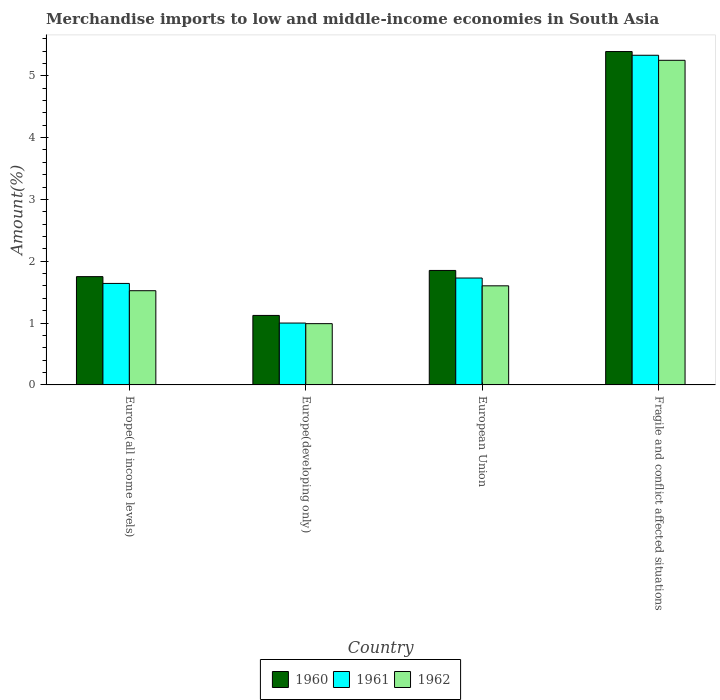How many different coloured bars are there?
Provide a short and direct response. 3. What is the label of the 4th group of bars from the left?
Your response must be concise. Fragile and conflict affected situations. What is the percentage of amount earned from merchandise imports in 1961 in Europe(developing only)?
Make the answer very short. 1. Across all countries, what is the maximum percentage of amount earned from merchandise imports in 1960?
Provide a short and direct response. 5.39. Across all countries, what is the minimum percentage of amount earned from merchandise imports in 1962?
Give a very brief answer. 0.99. In which country was the percentage of amount earned from merchandise imports in 1962 maximum?
Ensure brevity in your answer.  Fragile and conflict affected situations. In which country was the percentage of amount earned from merchandise imports in 1961 minimum?
Your answer should be compact. Europe(developing only). What is the total percentage of amount earned from merchandise imports in 1961 in the graph?
Offer a very short reply. 9.7. What is the difference between the percentage of amount earned from merchandise imports in 1962 in Europe(all income levels) and that in Fragile and conflict affected situations?
Your response must be concise. -3.73. What is the difference between the percentage of amount earned from merchandise imports in 1962 in Europe(developing only) and the percentage of amount earned from merchandise imports in 1960 in Fragile and conflict affected situations?
Offer a very short reply. -4.4. What is the average percentage of amount earned from merchandise imports in 1960 per country?
Provide a succinct answer. 2.53. What is the difference between the percentage of amount earned from merchandise imports of/in 1962 and percentage of amount earned from merchandise imports of/in 1961 in European Union?
Provide a short and direct response. -0.13. In how many countries, is the percentage of amount earned from merchandise imports in 1962 greater than 5.2 %?
Make the answer very short. 1. What is the ratio of the percentage of amount earned from merchandise imports in 1962 in Europe(all income levels) to that in European Union?
Your answer should be very brief. 0.95. Is the difference between the percentage of amount earned from merchandise imports in 1962 in Europe(developing only) and European Union greater than the difference between the percentage of amount earned from merchandise imports in 1961 in Europe(developing only) and European Union?
Give a very brief answer. Yes. What is the difference between the highest and the second highest percentage of amount earned from merchandise imports in 1961?
Provide a short and direct response. -3.6. What is the difference between the highest and the lowest percentage of amount earned from merchandise imports in 1960?
Keep it short and to the point. 4.27. In how many countries, is the percentage of amount earned from merchandise imports in 1960 greater than the average percentage of amount earned from merchandise imports in 1960 taken over all countries?
Your response must be concise. 1. Is the sum of the percentage of amount earned from merchandise imports in 1961 in Europe(all income levels) and European Union greater than the maximum percentage of amount earned from merchandise imports in 1962 across all countries?
Your answer should be compact. No. What does the 3rd bar from the left in Europe(developing only) represents?
Your response must be concise. 1962. How many countries are there in the graph?
Keep it short and to the point. 4. Does the graph contain any zero values?
Your answer should be compact. No. Where does the legend appear in the graph?
Your answer should be compact. Bottom center. How many legend labels are there?
Ensure brevity in your answer.  3. What is the title of the graph?
Offer a terse response. Merchandise imports to low and middle-income economies in South Asia. Does "1993" appear as one of the legend labels in the graph?
Make the answer very short. No. What is the label or title of the X-axis?
Keep it short and to the point. Country. What is the label or title of the Y-axis?
Make the answer very short. Amount(%). What is the Amount(%) in 1960 in Europe(all income levels)?
Give a very brief answer. 1.75. What is the Amount(%) of 1961 in Europe(all income levels)?
Your answer should be very brief. 1.64. What is the Amount(%) in 1962 in Europe(all income levels)?
Provide a succinct answer. 1.52. What is the Amount(%) of 1960 in Europe(developing only)?
Your answer should be compact. 1.12. What is the Amount(%) of 1961 in Europe(developing only)?
Your answer should be very brief. 1. What is the Amount(%) in 1962 in Europe(developing only)?
Your answer should be very brief. 0.99. What is the Amount(%) of 1960 in European Union?
Provide a succinct answer. 1.85. What is the Amount(%) of 1961 in European Union?
Keep it short and to the point. 1.73. What is the Amount(%) in 1962 in European Union?
Ensure brevity in your answer.  1.6. What is the Amount(%) of 1960 in Fragile and conflict affected situations?
Provide a short and direct response. 5.39. What is the Amount(%) of 1961 in Fragile and conflict affected situations?
Your answer should be very brief. 5.33. What is the Amount(%) in 1962 in Fragile and conflict affected situations?
Give a very brief answer. 5.25. Across all countries, what is the maximum Amount(%) in 1960?
Your answer should be compact. 5.39. Across all countries, what is the maximum Amount(%) of 1961?
Provide a short and direct response. 5.33. Across all countries, what is the maximum Amount(%) of 1962?
Ensure brevity in your answer.  5.25. Across all countries, what is the minimum Amount(%) of 1960?
Keep it short and to the point. 1.12. Across all countries, what is the minimum Amount(%) in 1961?
Your response must be concise. 1. Across all countries, what is the minimum Amount(%) of 1962?
Your response must be concise. 0.99. What is the total Amount(%) of 1960 in the graph?
Your answer should be compact. 10.12. What is the total Amount(%) in 1961 in the graph?
Keep it short and to the point. 9.7. What is the total Amount(%) in 1962 in the graph?
Keep it short and to the point. 9.37. What is the difference between the Amount(%) of 1960 in Europe(all income levels) and that in Europe(developing only)?
Provide a short and direct response. 0.63. What is the difference between the Amount(%) of 1961 in Europe(all income levels) and that in Europe(developing only)?
Give a very brief answer. 0.64. What is the difference between the Amount(%) of 1962 in Europe(all income levels) and that in Europe(developing only)?
Provide a short and direct response. 0.53. What is the difference between the Amount(%) in 1960 in Europe(all income levels) and that in European Union?
Ensure brevity in your answer.  -0.1. What is the difference between the Amount(%) in 1961 in Europe(all income levels) and that in European Union?
Offer a terse response. -0.09. What is the difference between the Amount(%) of 1962 in Europe(all income levels) and that in European Union?
Make the answer very short. -0.08. What is the difference between the Amount(%) of 1960 in Europe(all income levels) and that in Fragile and conflict affected situations?
Your answer should be compact. -3.64. What is the difference between the Amount(%) in 1961 in Europe(all income levels) and that in Fragile and conflict affected situations?
Ensure brevity in your answer.  -3.69. What is the difference between the Amount(%) of 1962 in Europe(all income levels) and that in Fragile and conflict affected situations?
Your answer should be compact. -3.73. What is the difference between the Amount(%) in 1960 in Europe(developing only) and that in European Union?
Ensure brevity in your answer.  -0.73. What is the difference between the Amount(%) in 1961 in Europe(developing only) and that in European Union?
Offer a terse response. -0.73. What is the difference between the Amount(%) in 1962 in Europe(developing only) and that in European Union?
Your response must be concise. -0.61. What is the difference between the Amount(%) in 1960 in Europe(developing only) and that in Fragile and conflict affected situations?
Your answer should be compact. -4.27. What is the difference between the Amount(%) of 1961 in Europe(developing only) and that in Fragile and conflict affected situations?
Keep it short and to the point. -4.33. What is the difference between the Amount(%) in 1962 in Europe(developing only) and that in Fragile and conflict affected situations?
Your answer should be compact. -4.26. What is the difference between the Amount(%) in 1960 in European Union and that in Fragile and conflict affected situations?
Provide a succinct answer. -3.54. What is the difference between the Amount(%) in 1961 in European Union and that in Fragile and conflict affected situations?
Offer a very short reply. -3.6. What is the difference between the Amount(%) of 1962 in European Union and that in Fragile and conflict affected situations?
Keep it short and to the point. -3.65. What is the difference between the Amount(%) of 1960 in Europe(all income levels) and the Amount(%) of 1961 in Europe(developing only)?
Provide a succinct answer. 0.75. What is the difference between the Amount(%) in 1960 in Europe(all income levels) and the Amount(%) in 1962 in Europe(developing only)?
Make the answer very short. 0.76. What is the difference between the Amount(%) in 1961 in Europe(all income levels) and the Amount(%) in 1962 in Europe(developing only)?
Ensure brevity in your answer.  0.65. What is the difference between the Amount(%) in 1960 in Europe(all income levels) and the Amount(%) in 1961 in European Union?
Provide a succinct answer. 0.02. What is the difference between the Amount(%) of 1960 in Europe(all income levels) and the Amount(%) of 1962 in European Union?
Ensure brevity in your answer.  0.15. What is the difference between the Amount(%) of 1961 in Europe(all income levels) and the Amount(%) of 1962 in European Union?
Offer a terse response. 0.04. What is the difference between the Amount(%) in 1960 in Europe(all income levels) and the Amount(%) in 1961 in Fragile and conflict affected situations?
Ensure brevity in your answer.  -3.58. What is the difference between the Amount(%) of 1960 in Europe(all income levels) and the Amount(%) of 1962 in Fragile and conflict affected situations?
Your answer should be very brief. -3.5. What is the difference between the Amount(%) in 1961 in Europe(all income levels) and the Amount(%) in 1962 in Fragile and conflict affected situations?
Your answer should be very brief. -3.61. What is the difference between the Amount(%) in 1960 in Europe(developing only) and the Amount(%) in 1961 in European Union?
Offer a very short reply. -0.61. What is the difference between the Amount(%) in 1960 in Europe(developing only) and the Amount(%) in 1962 in European Union?
Make the answer very short. -0.48. What is the difference between the Amount(%) of 1961 in Europe(developing only) and the Amount(%) of 1962 in European Union?
Your answer should be compact. -0.6. What is the difference between the Amount(%) of 1960 in Europe(developing only) and the Amount(%) of 1961 in Fragile and conflict affected situations?
Offer a terse response. -4.21. What is the difference between the Amount(%) of 1960 in Europe(developing only) and the Amount(%) of 1962 in Fragile and conflict affected situations?
Offer a terse response. -4.13. What is the difference between the Amount(%) in 1961 in Europe(developing only) and the Amount(%) in 1962 in Fragile and conflict affected situations?
Ensure brevity in your answer.  -4.25. What is the difference between the Amount(%) of 1960 in European Union and the Amount(%) of 1961 in Fragile and conflict affected situations?
Offer a terse response. -3.48. What is the difference between the Amount(%) in 1960 in European Union and the Amount(%) in 1962 in Fragile and conflict affected situations?
Offer a very short reply. -3.4. What is the difference between the Amount(%) of 1961 in European Union and the Amount(%) of 1962 in Fragile and conflict affected situations?
Provide a succinct answer. -3.52. What is the average Amount(%) of 1960 per country?
Make the answer very short. 2.53. What is the average Amount(%) in 1961 per country?
Ensure brevity in your answer.  2.43. What is the average Amount(%) in 1962 per country?
Ensure brevity in your answer.  2.34. What is the difference between the Amount(%) of 1960 and Amount(%) of 1961 in Europe(all income levels)?
Offer a terse response. 0.11. What is the difference between the Amount(%) in 1960 and Amount(%) in 1962 in Europe(all income levels)?
Your answer should be very brief. 0.23. What is the difference between the Amount(%) in 1961 and Amount(%) in 1962 in Europe(all income levels)?
Your answer should be compact. 0.12. What is the difference between the Amount(%) in 1960 and Amount(%) in 1961 in Europe(developing only)?
Give a very brief answer. 0.12. What is the difference between the Amount(%) of 1960 and Amount(%) of 1962 in Europe(developing only)?
Keep it short and to the point. 0.13. What is the difference between the Amount(%) in 1961 and Amount(%) in 1962 in Europe(developing only)?
Your response must be concise. 0.01. What is the difference between the Amount(%) of 1960 and Amount(%) of 1961 in European Union?
Ensure brevity in your answer.  0.12. What is the difference between the Amount(%) of 1960 and Amount(%) of 1962 in European Union?
Ensure brevity in your answer.  0.25. What is the difference between the Amount(%) of 1961 and Amount(%) of 1962 in European Union?
Your answer should be very brief. 0.13. What is the difference between the Amount(%) in 1960 and Amount(%) in 1961 in Fragile and conflict affected situations?
Offer a terse response. 0.06. What is the difference between the Amount(%) in 1960 and Amount(%) in 1962 in Fragile and conflict affected situations?
Keep it short and to the point. 0.14. What is the difference between the Amount(%) in 1961 and Amount(%) in 1962 in Fragile and conflict affected situations?
Your response must be concise. 0.08. What is the ratio of the Amount(%) of 1960 in Europe(all income levels) to that in Europe(developing only)?
Your answer should be very brief. 1.56. What is the ratio of the Amount(%) in 1961 in Europe(all income levels) to that in Europe(developing only)?
Make the answer very short. 1.64. What is the ratio of the Amount(%) of 1962 in Europe(all income levels) to that in Europe(developing only)?
Keep it short and to the point. 1.54. What is the ratio of the Amount(%) of 1960 in Europe(all income levels) to that in European Union?
Offer a terse response. 0.95. What is the ratio of the Amount(%) of 1961 in Europe(all income levels) to that in European Union?
Ensure brevity in your answer.  0.95. What is the ratio of the Amount(%) of 1962 in Europe(all income levels) to that in European Union?
Make the answer very short. 0.95. What is the ratio of the Amount(%) of 1960 in Europe(all income levels) to that in Fragile and conflict affected situations?
Offer a very short reply. 0.32. What is the ratio of the Amount(%) in 1961 in Europe(all income levels) to that in Fragile and conflict affected situations?
Your answer should be very brief. 0.31. What is the ratio of the Amount(%) of 1962 in Europe(all income levels) to that in Fragile and conflict affected situations?
Ensure brevity in your answer.  0.29. What is the ratio of the Amount(%) of 1960 in Europe(developing only) to that in European Union?
Your answer should be very brief. 0.61. What is the ratio of the Amount(%) in 1961 in Europe(developing only) to that in European Union?
Offer a terse response. 0.58. What is the ratio of the Amount(%) of 1962 in Europe(developing only) to that in European Union?
Ensure brevity in your answer.  0.62. What is the ratio of the Amount(%) in 1960 in Europe(developing only) to that in Fragile and conflict affected situations?
Your answer should be very brief. 0.21. What is the ratio of the Amount(%) in 1961 in Europe(developing only) to that in Fragile and conflict affected situations?
Make the answer very short. 0.19. What is the ratio of the Amount(%) in 1962 in Europe(developing only) to that in Fragile and conflict affected situations?
Provide a succinct answer. 0.19. What is the ratio of the Amount(%) of 1960 in European Union to that in Fragile and conflict affected situations?
Offer a very short reply. 0.34. What is the ratio of the Amount(%) of 1961 in European Union to that in Fragile and conflict affected situations?
Provide a succinct answer. 0.32. What is the ratio of the Amount(%) of 1962 in European Union to that in Fragile and conflict affected situations?
Provide a short and direct response. 0.31. What is the difference between the highest and the second highest Amount(%) of 1960?
Make the answer very short. 3.54. What is the difference between the highest and the second highest Amount(%) in 1961?
Ensure brevity in your answer.  3.6. What is the difference between the highest and the second highest Amount(%) of 1962?
Your answer should be compact. 3.65. What is the difference between the highest and the lowest Amount(%) in 1960?
Your answer should be very brief. 4.27. What is the difference between the highest and the lowest Amount(%) in 1961?
Offer a terse response. 4.33. What is the difference between the highest and the lowest Amount(%) of 1962?
Make the answer very short. 4.26. 